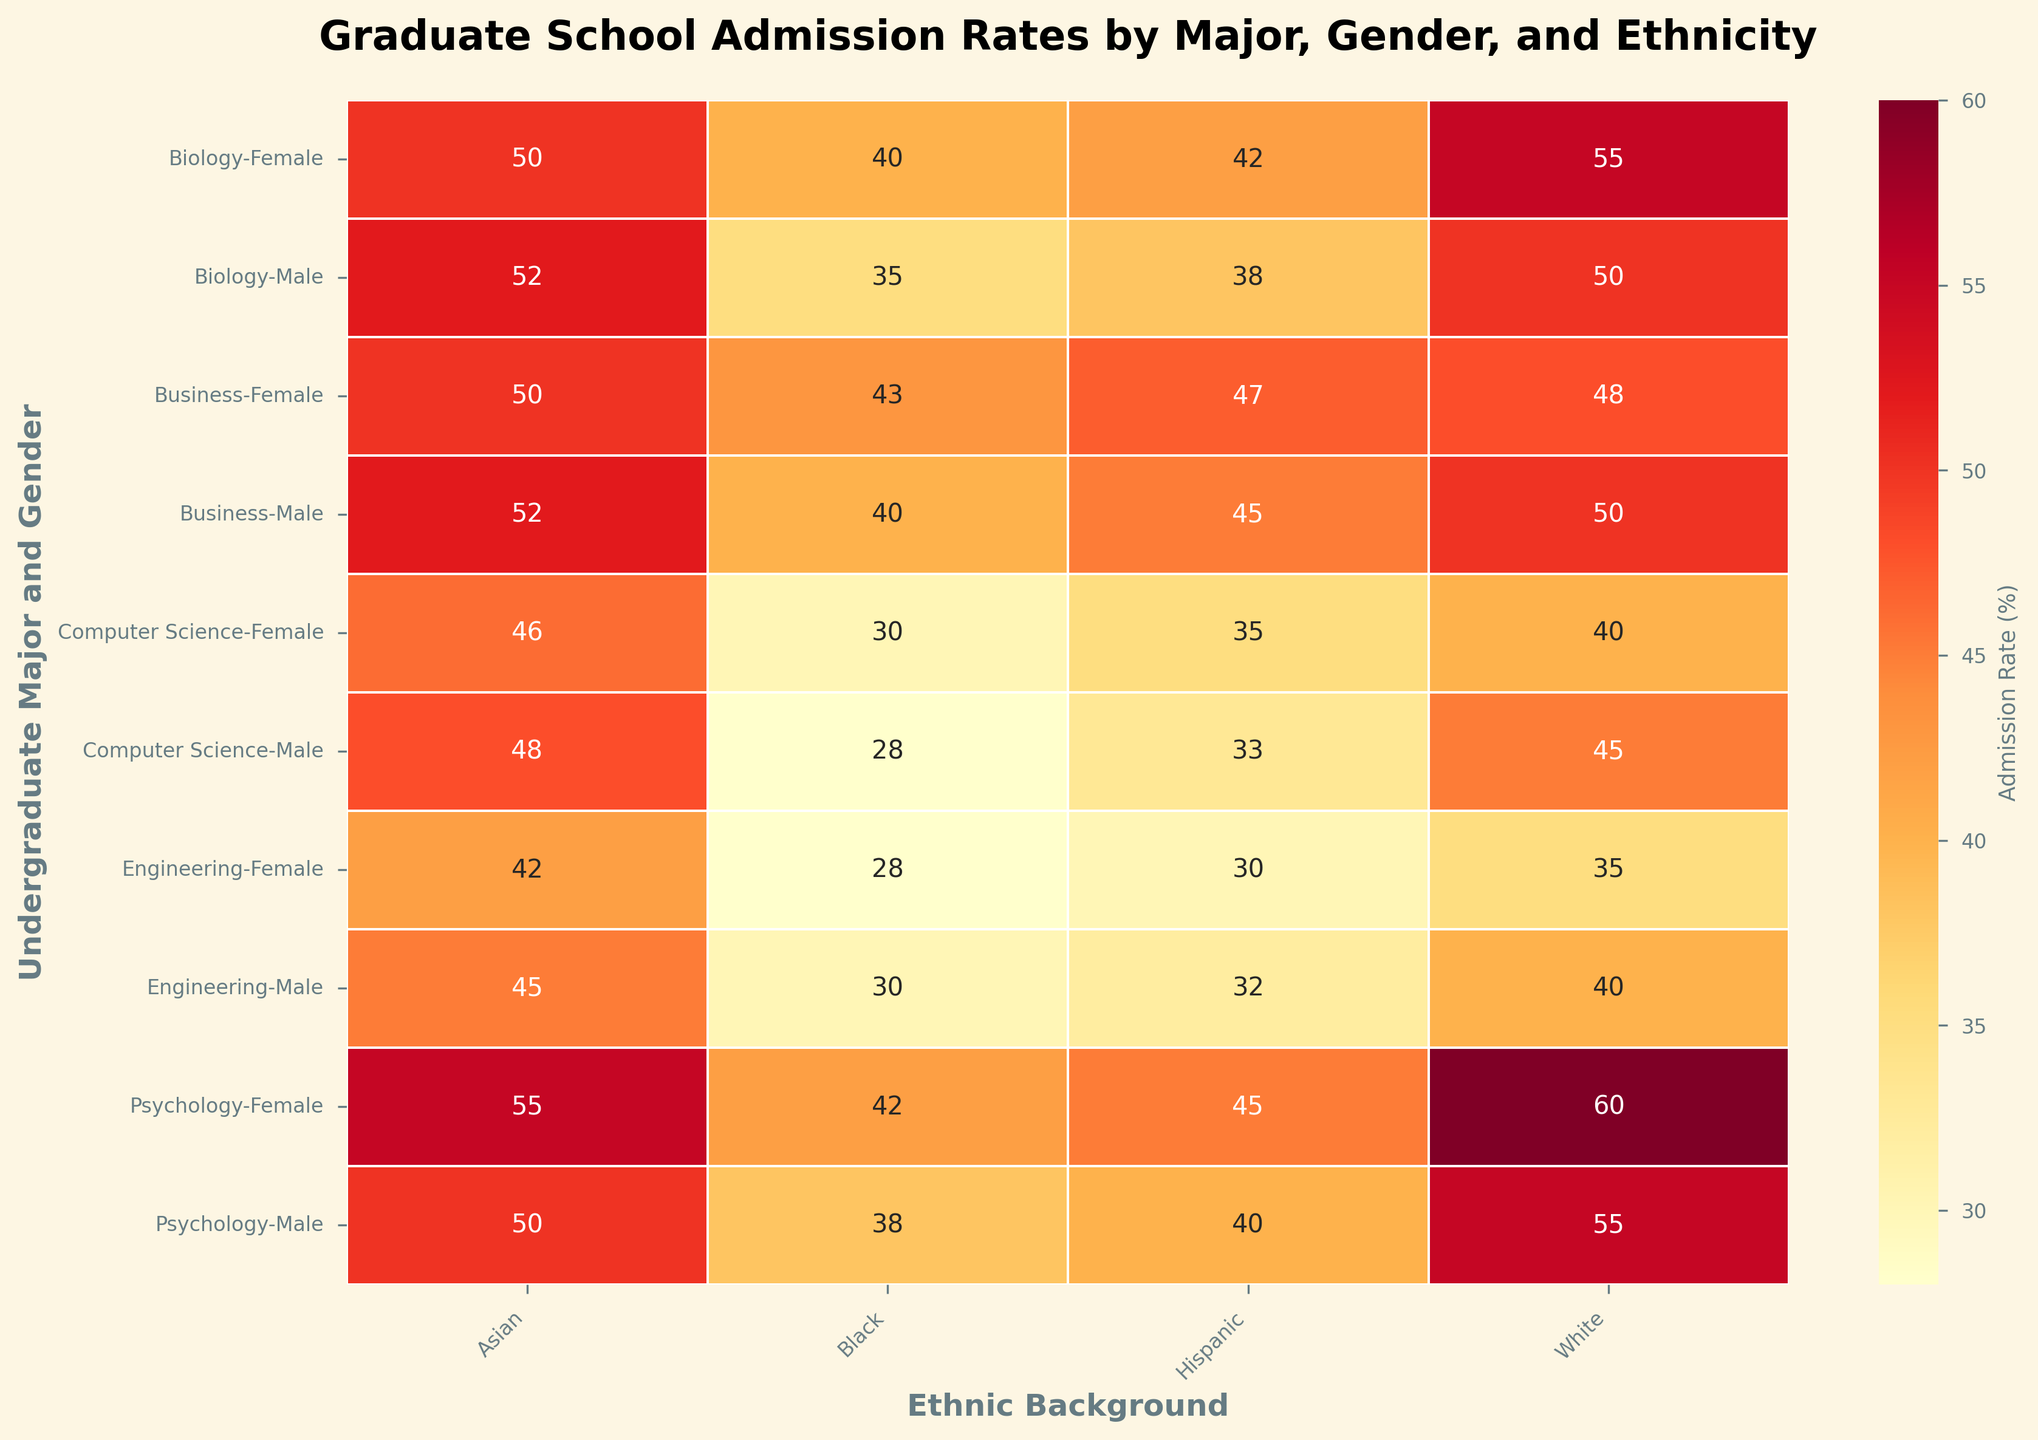What is the title of the heatmap figure? The title is positioned at the top of the heatmap and is designed to provide a summary of what the figure represents. Reading the title will give us a quick understanding of the subject of the heatmap.
Answer: Graduate School Admission Rates by Major, Gender, and Ethnicity Which undergraduate major and gender have the highest admission rate for Hispanic students? To find the highest admission rate for Hispanic students, locate the column labeled "Hispanic" and scan through the values. Identify the row with the highest value and note the corresponding undergraduate major and gender.
Answer: Psychology, Female Which ethnic background has the overall lowest admission rate for both genders in Computer Science? Look at the "Computer Science" rows and identify the lowest admission rate within each gender under different ethnic backgrounds. Compare values from both genders to find the overall lowest rate.
Answer: Black Which gender generally has higher admission rates in Psychology for White and Asian students? Compare the admission rates of Male and Female in Psychology for both White and Asian students. Verify which gender has higher rates in both ethnic backgrounds.
Answer: Female Is the admission rate for Male students in Biology generally higher or lower compared to Female students in the same major? Check the admission rates for Male and Female students in Biology across all ethnicities. Compare each rate to determine whether Male rates are generally higher or lower.
Answer: Lower Which undergraduate major shows the smallest gender disparity in admission rates for Hispanic students? Check the admission rates for Male and Female Hispanic students across all majors. Calculate the absolute difference for each major and identify the smallest disparity.
Answer: Biology 